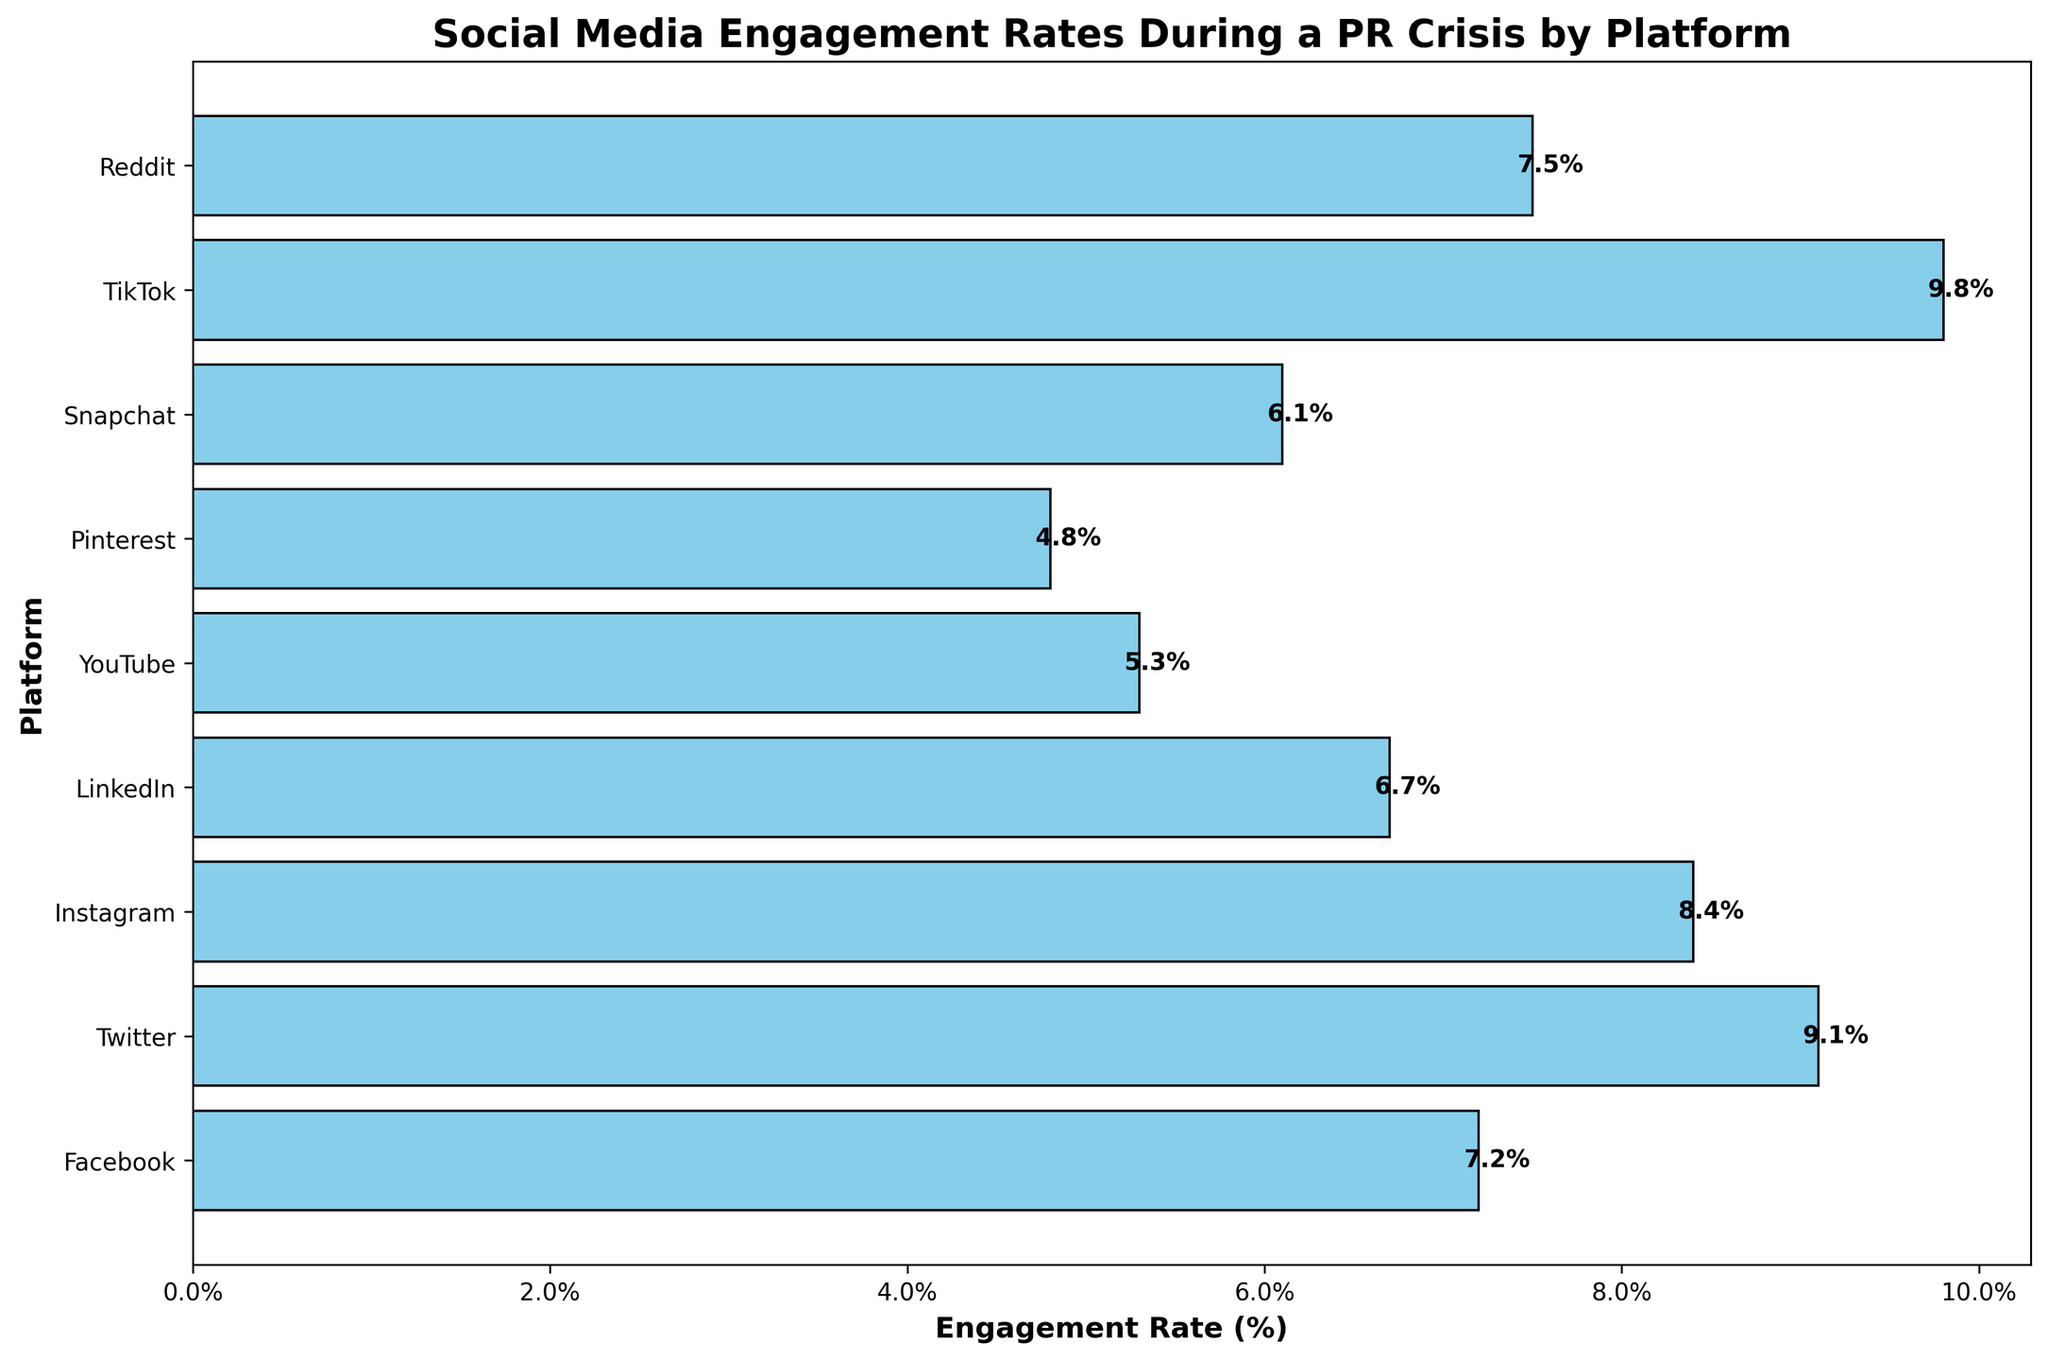Which platform has the highest engagement rate during the PR crisis? Look at the bars representing each platform's engagement rate to identify the one with the greatest length. The longest bar shows the highest engagement rate.
Answer: TikTok What is the engagement rate difference between Twitter and YouTube? Look at the engagement rates for Twitter and YouTube and subtract the smaller value from the larger one. Twitter is at 9.1% and YouTube is at 5.3%. Calculate 9.1 - 5.3
Answer: 3.8% What's the average engagement rate for Facebook, Instagram, and LinkedIn? Add the engagement rates for Facebook (7.2%), Instagram (8.4%) and LinkedIn (6.7%), then divide by 3 to find the average: (7.2 + 8.4 + 6.7) / 3.
Answer: 7.43% Are there more platforms with engagement rates above or below 7.0%? Count the number of platforms with engagement rates above 7.0% and those below 7.0%. Above 7.0% = Facebook, Twitter, Instagram, TikTok, Reddit; Below 7.0% = LinkedIn, YouTube, Pinterest, Snapchat. There are 5 platforms above and 4 platforms below.
Answer: Above Which platform has the lowest engagement rate during the PR crisis? Look at the bars representing each platform and identify the one with the smallest length. The shortest bar shows the lowest engagement rate.
Answer: Pinterest How much higher is TikTok's engagement rate compared to Snapchat's? Find TikTok's engagement rate (9.8%) and Snapchat's rate (6.1%), then subtract the smaller from the larger: 9.8% - 6.1%.
Answer: 3.7% What is the total engagement rate of all platforms combined? Sum the engagement rates of all platforms: 7.2 + 9.1 + 8.4 + 6.7 + 5.3 + 4.8 + 6.1 + 9.8 + 7.5.
Answer: 64.9% Which platform has the closest engagement rate to the overall average of all platforms? Calculate the average engagement rate: 64.9 / 9 ≈ 7.21%. Identify which platform's engagement rate most closely matches this average. Facebook (7.2%) and Reddit (7.5%) are close, but Facebook is closer.
Answer: Facebook How does the engagement rate of Reddit compare to LinkedIn? Compare the engagement rates of Reddit (7.5%) and LinkedIn (6.7%). Since 7.5% is greater than 6.7%, Reddit has a higher engagement rate.
Answer: Reddit has a higher engagement rate than LinkedIn What is the engagement rate range across all platforms? Identify the maximum and minimum engagement rates (TikTok at 9.8% and Pinterest at 4.8%), then subtract the minimum from the maximum: 9.8% - 4.8%.
Answer: 5.0% 